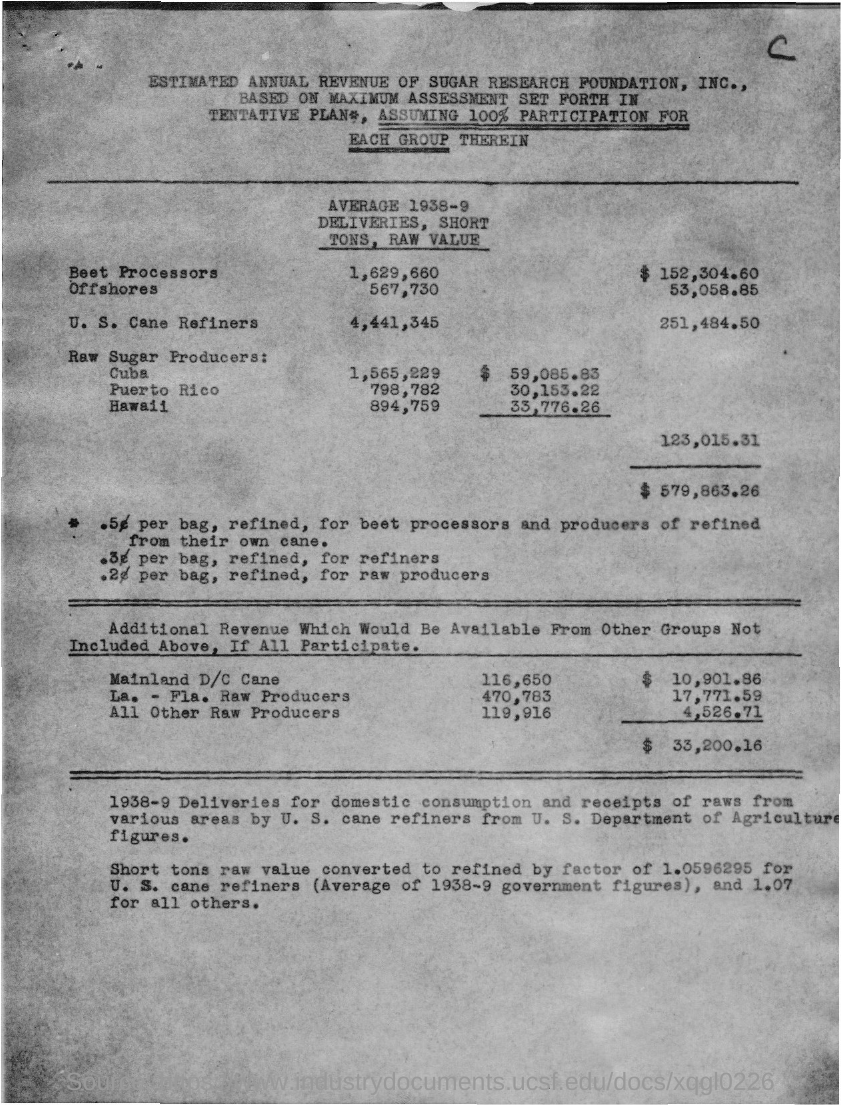Identify some key points in this picture. The first country to be referred to as a "Raw Sugar Producer" is Cuba. In 1938-9, a total of 567,730 short tons of raw value deliveries were made to Offshores. In the year 1938-9, a total of 798,782 short tons of raw materials were delivered to Puerto Rico. The "AVERAGAE 1938-9 DELIVERIES, SHORT TONS, RAW VALUE" of Cuba was 1,565,229 short tons. The document mentions the average delivery of raw beet tons in 1938-9 by Beet Processors, which was 1,629,660. 